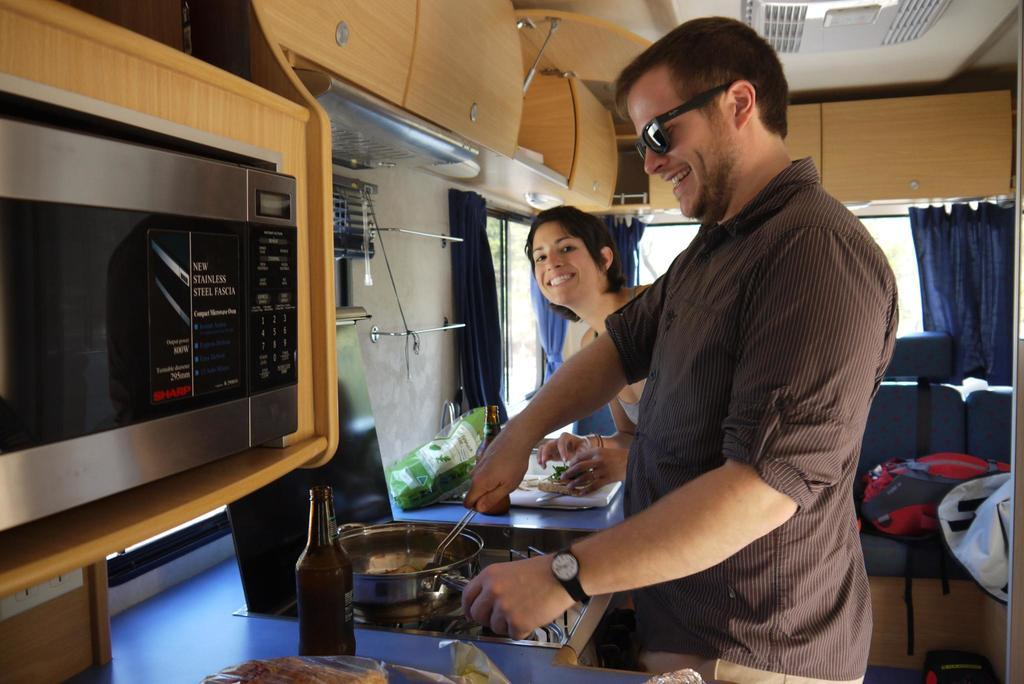<image>
Summarize the visual content of the image. A man cooking next to a microwave with a sign that says "new stainless steel fascia" 